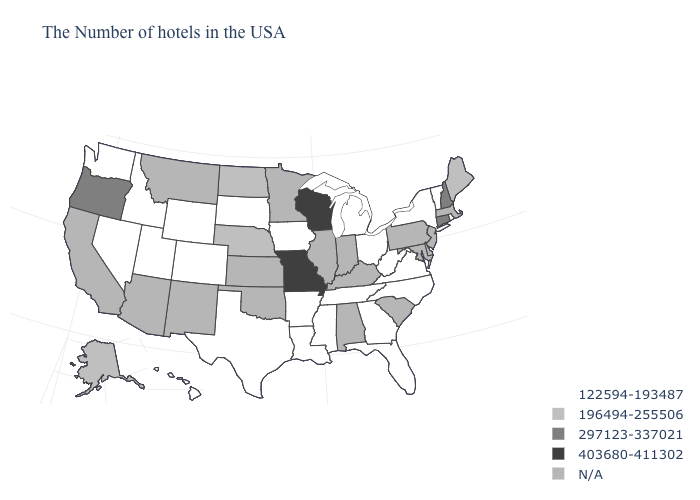Among the states that border Texas , which have the lowest value?
Answer briefly. Louisiana, Arkansas. What is the value of Indiana?
Write a very short answer. N/A. Does Connecticut have the lowest value in the USA?
Write a very short answer. No. What is the lowest value in the Northeast?
Quick response, please. 122594-193487. Which states hav the highest value in the MidWest?
Keep it brief. Wisconsin, Missouri. Does Ohio have the lowest value in the MidWest?
Give a very brief answer. Yes. Does Wyoming have the lowest value in the USA?
Be succinct. Yes. What is the highest value in states that border Tennessee?
Keep it brief. 403680-411302. What is the highest value in the West ?
Keep it brief. 297123-337021. What is the value of Alabama?
Short answer required. N/A. Does the first symbol in the legend represent the smallest category?
Quick response, please. Yes. Name the states that have a value in the range N/A?
Give a very brief answer. Massachusetts, New Jersey, Delaware, Maryland, Pennsylvania, South Carolina, Kentucky, Indiana, Alabama, Illinois, Minnesota, Kansas, Oklahoma, New Mexico, Montana, Arizona, California. 